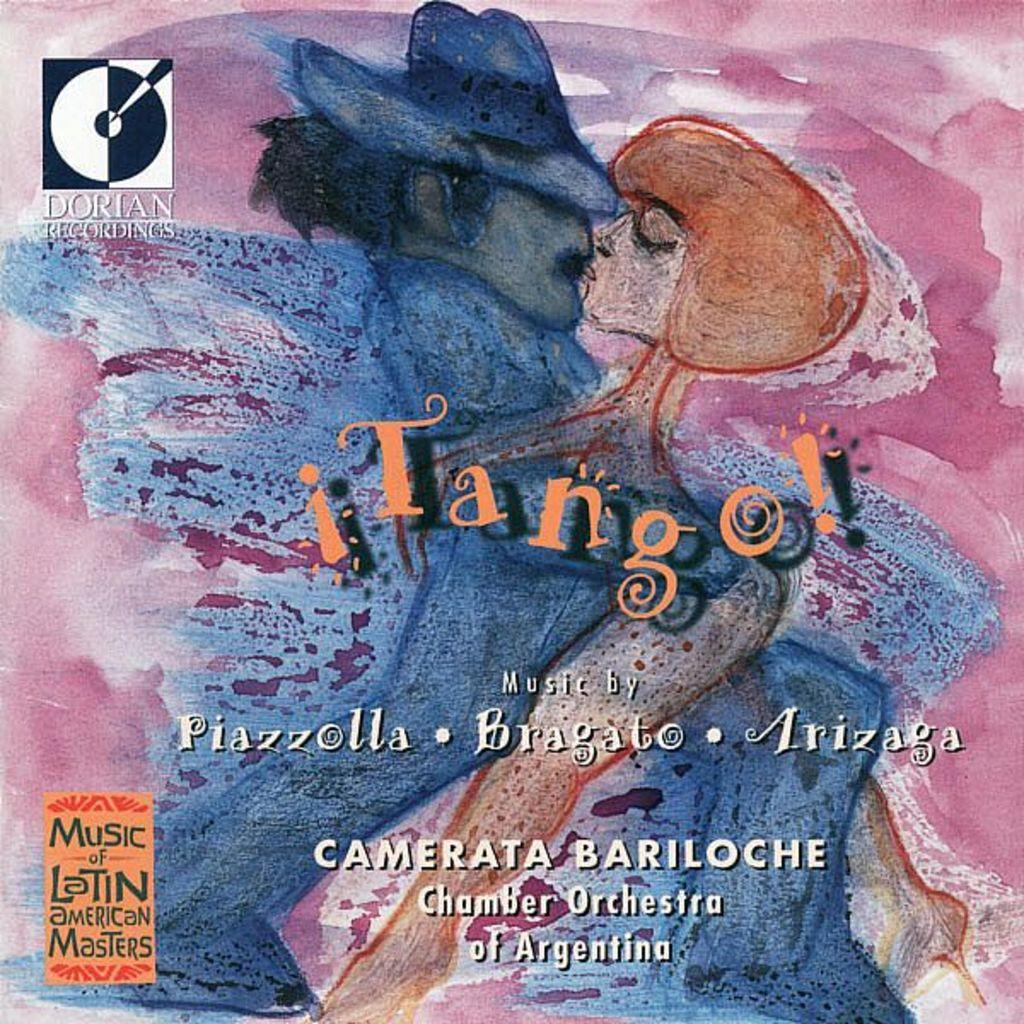<image>
Present a compact description of the photo's key features. A painting for a record cover shows a man and a lady kissing and is called Tango!, music by Piazzolla, Bragato, and Arizaga. 